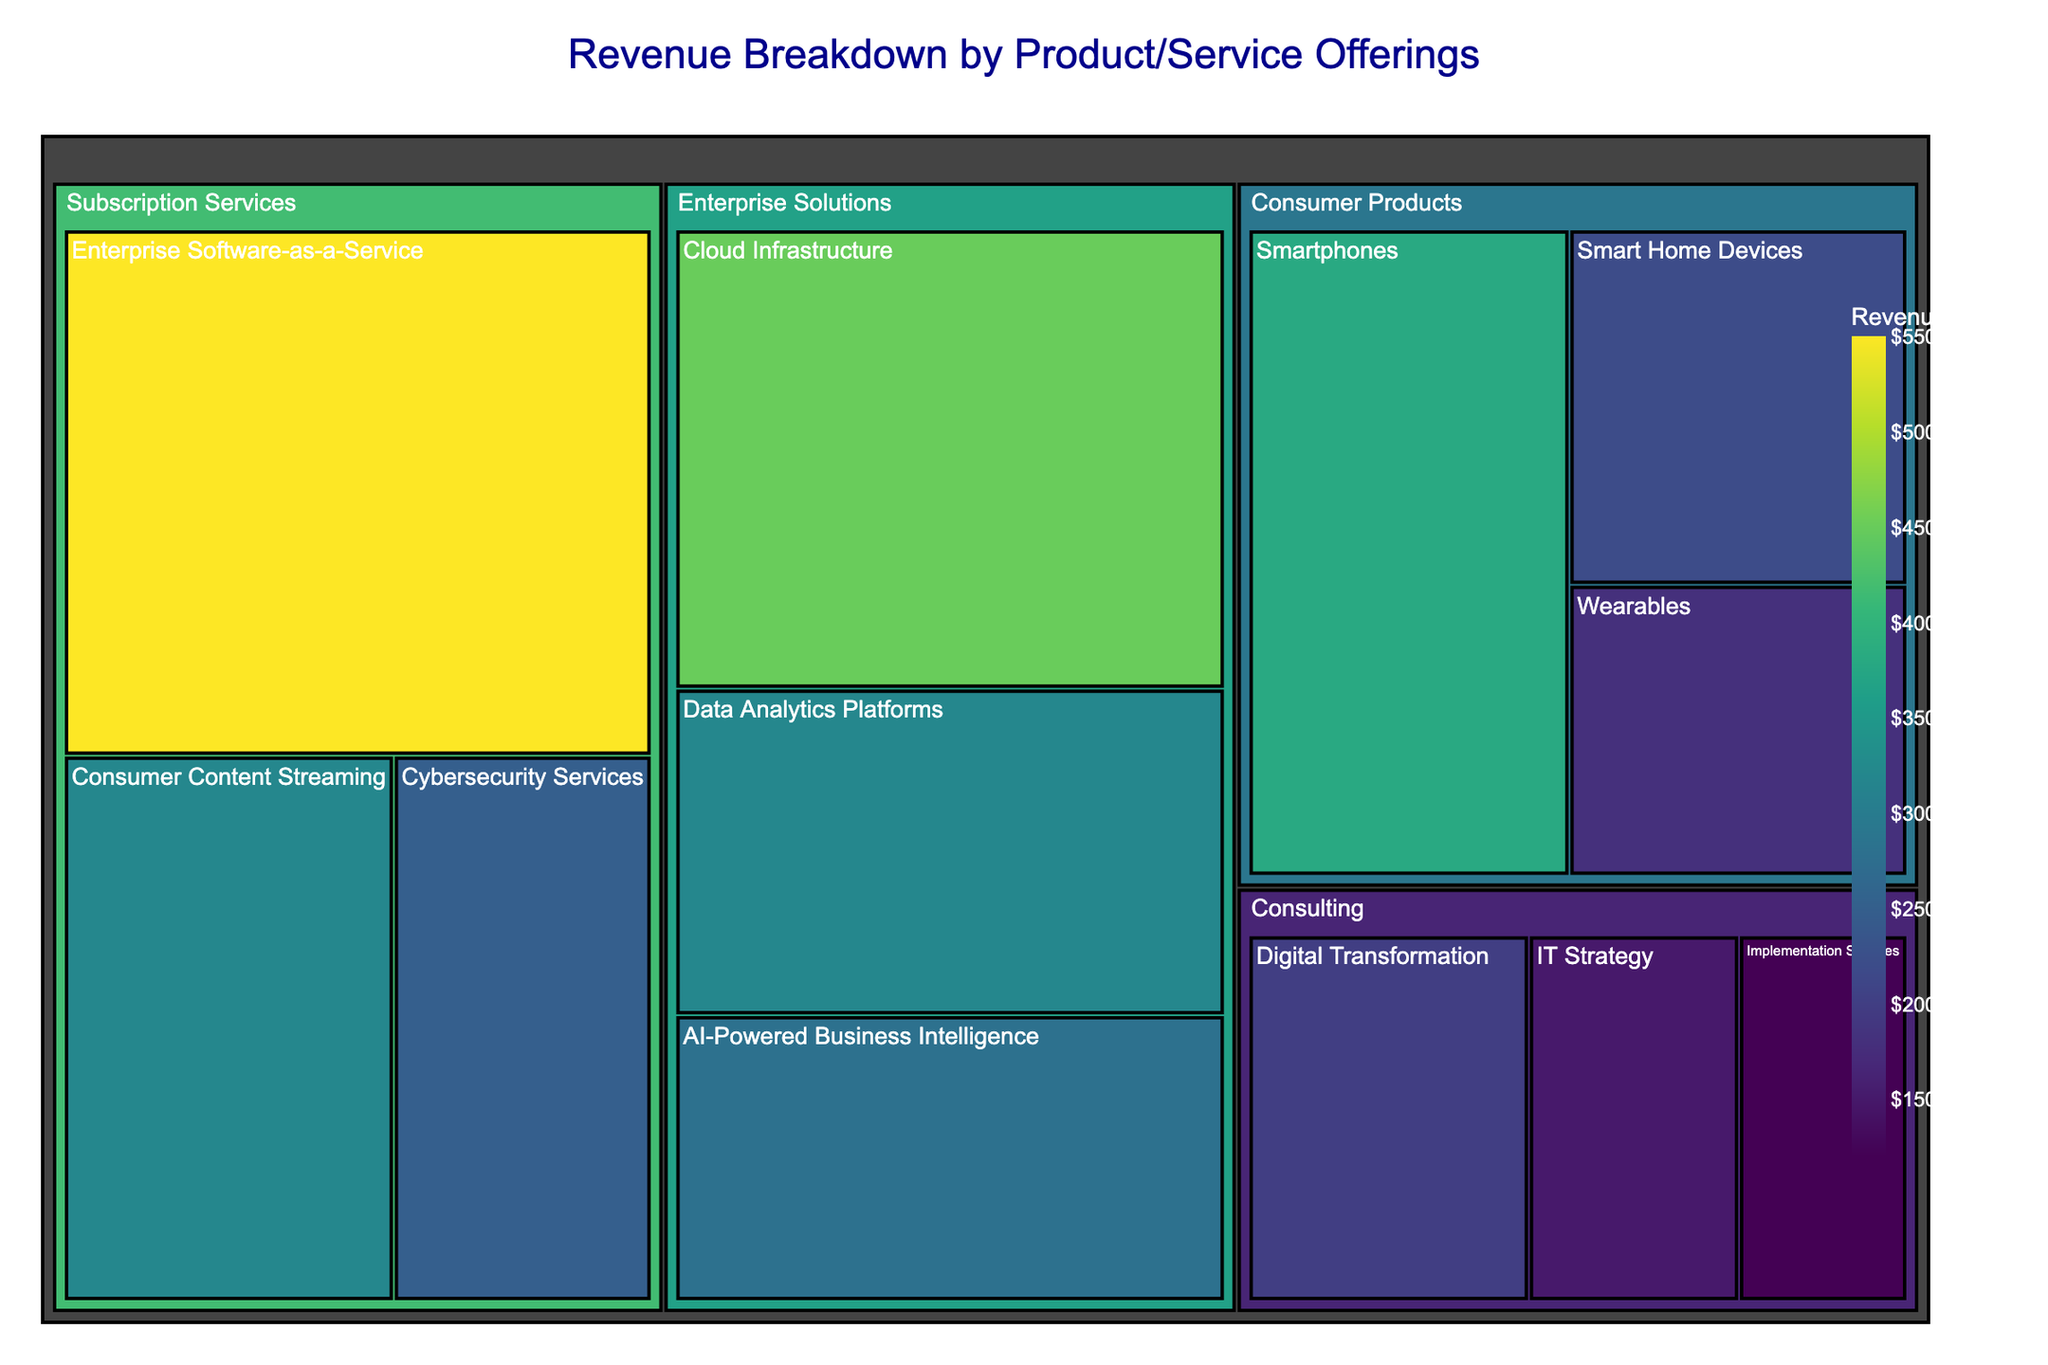what's the title of the treemap? The title is located at the top of the treemap, usually in larger and bold font. In this case, it reads "Revenue Breakdown by Product/Service Offerings".
Answer: Revenue Breakdown by Product/Service Offerings which subcategory within Enterprise Solutions has the highest revenue? Look for the Enterprise Solutions category and compare the revenue of its subcategories (Cloud Infrastructure, Data Analytics Platforms, AI-Powered Business Intelligence). Cloud Infrastructure has the largest area, indicating the highest revenue.
Answer: Cloud Infrastructure what is the combined revenue of Consulting subcategories? Find the revenue for each Consulting subcategory (Digital Transformation, IT Strategy, Implementation Services) and add them together: $200M + $150M + $120M = $470M.
Answer: $470M which category has the smallest revenue, and what is its amount? Compare the total revenues of each main category (Enterprise Solutions, Consumer Products, Subscription Services, Consulting) by observing the area size. Consulting is the smallest. Add its subcategories' revenues: $200M + $150M + $120M = $470M.
Answer: Consulting with $470M which has a larger revenue, AI-Powered Business Intelligence from Enterprise Solutions or Consumer Content Streaming from Subscription Services? Compare the revenues of the two subcategories directly by their area size. AI-Powered Business Intelligence has $280M, and Consumer Content Streaming has $320M.
Answer: Consumer Content Streaming how does the revenue for Smart Home Devices compare to Wearables in Consumer Products? Examine the areas of both subcategories within Consumer Products. Smart Home Devices has a revenue of $220M, while Wearables has $180M. Smart Home Devices has a larger revenue.
Answer: Smart Home Devices has larger revenue what percentage of total revenue does Enterprise Software-as-a-Service contribute to Subscription Services? First, find the total revenue for Subscription Services by summing its subcategories: $550M + $320M + $250M = $1120M. Then, calculate the percentage: ($550M / $1120M) * 100 ≈ 49.1%.
Answer: Approximately 49.1% how much more revenue does Enterprise Solutions generate compared to Consulting? Calculate the total revenue for Enterprise Solutions: $450M + $320M + $280M = $1050M. Total revenue for Consulting is $470M. Subtract Consulting's revenue from Enterprise Solutions’: $1050M - $470M = $580M.
Answer: $580M what is the ratio of revenue between Consumer Products and Subscription Services? Calculate the total revenue for Consumer Products: $380M + $220M + $180M = $780M. The total revenue for Subscription Services is $1120M. Find the ratio by dividing Consumer Products' revenue by Subscription Services': $780M / $1120M = 0.696.
Answer: 0.696 